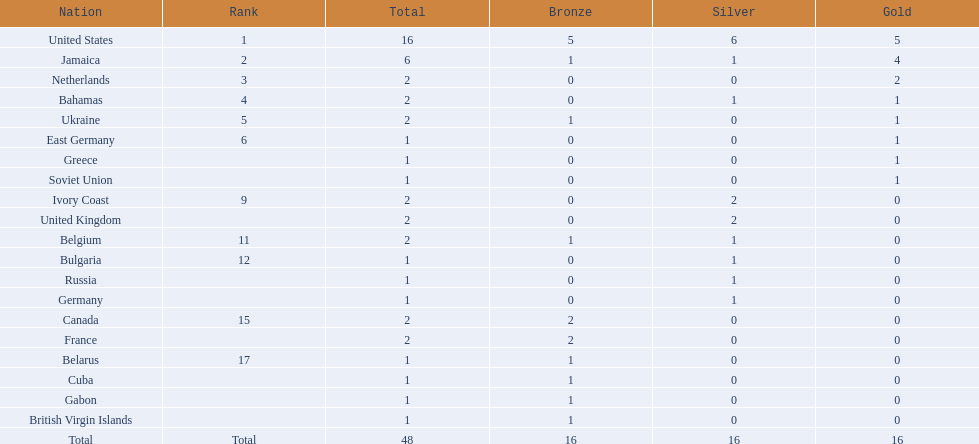Which countries competed in the 60 meters competition? United States, Jamaica, Netherlands, Bahamas, Ukraine, East Germany, Greece, Soviet Union, Ivory Coast, United Kingdom, Belgium, Bulgaria, Russia, Germany, Canada, France, Belarus, Cuba, Gabon, British Virgin Islands. Parse the table in full. {'header': ['Nation', 'Rank', 'Total', 'Bronze', 'Silver', 'Gold'], 'rows': [['United States', '1', '16', '5', '6', '5'], ['Jamaica', '2', '6', '1', '1', '4'], ['Netherlands', '3', '2', '0', '0', '2'], ['Bahamas', '4', '2', '0', '1', '1'], ['Ukraine', '5', '2', '1', '0', '1'], ['East Germany', '6', '1', '0', '0', '1'], ['Greece', '', '1', '0', '0', '1'], ['Soviet Union', '', '1', '0', '0', '1'], ['Ivory Coast', '9', '2', '0', '2', '0'], ['United Kingdom', '', '2', '0', '2', '0'], ['Belgium', '11', '2', '1', '1', '0'], ['Bulgaria', '12', '1', '0', '1', '0'], ['Russia', '', '1', '0', '1', '0'], ['Germany', '', '1', '0', '1', '0'], ['Canada', '15', '2', '2', '0', '0'], ['France', '', '2', '2', '0', '0'], ['Belarus', '17', '1', '1', '0', '0'], ['Cuba', '', '1', '1', '0', '0'], ['Gabon', '', '1', '1', '0', '0'], ['British Virgin Islands', '', '1', '1', '0', '0'], ['Total', 'Total', '48', '16', '16', '16']]} And how many gold medals did they win? 5, 4, 2, 1, 1, 1, 1, 1, 0, 0, 0, 0, 0, 0, 0, 0, 0, 0, 0, 0. Of those countries, which won the second highest number gold medals? Jamaica. 